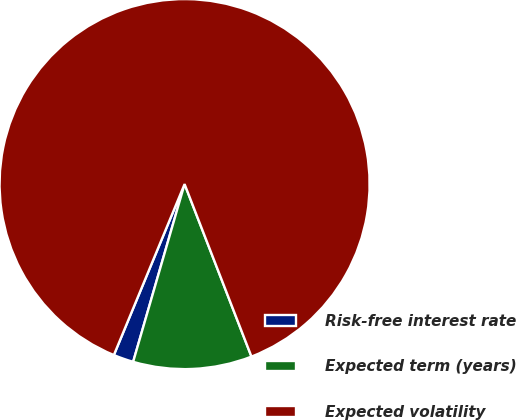Convert chart to OTSL. <chart><loc_0><loc_0><loc_500><loc_500><pie_chart><fcel>Risk-free interest rate<fcel>Expected term (years)<fcel>Expected volatility<nl><fcel>1.76%<fcel>10.37%<fcel>87.87%<nl></chart> 